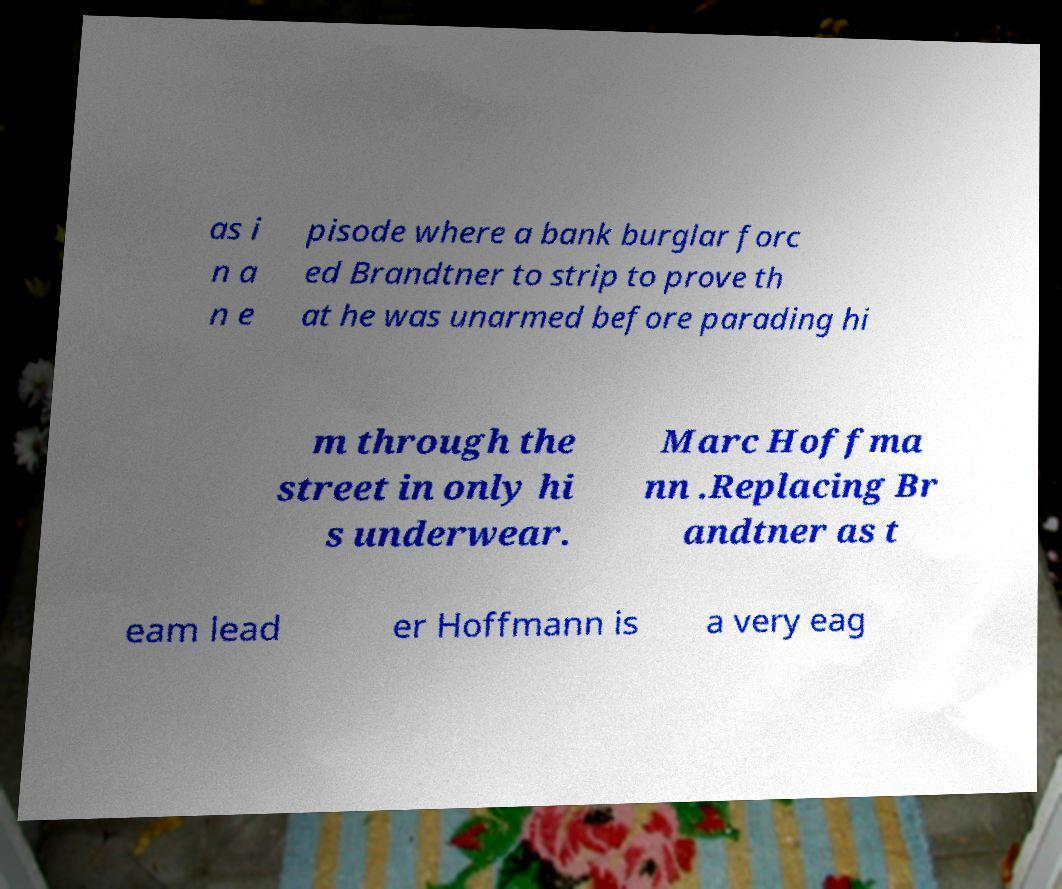Could you assist in decoding the text presented in this image and type it out clearly? as i n a n e pisode where a bank burglar forc ed Brandtner to strip to prove th at he was unarmed before parading hi m through the street in only hi s underwear. Marc Hoffma nn .Replacing Br andtner as t eam lead er Hoffmann is a very eag 